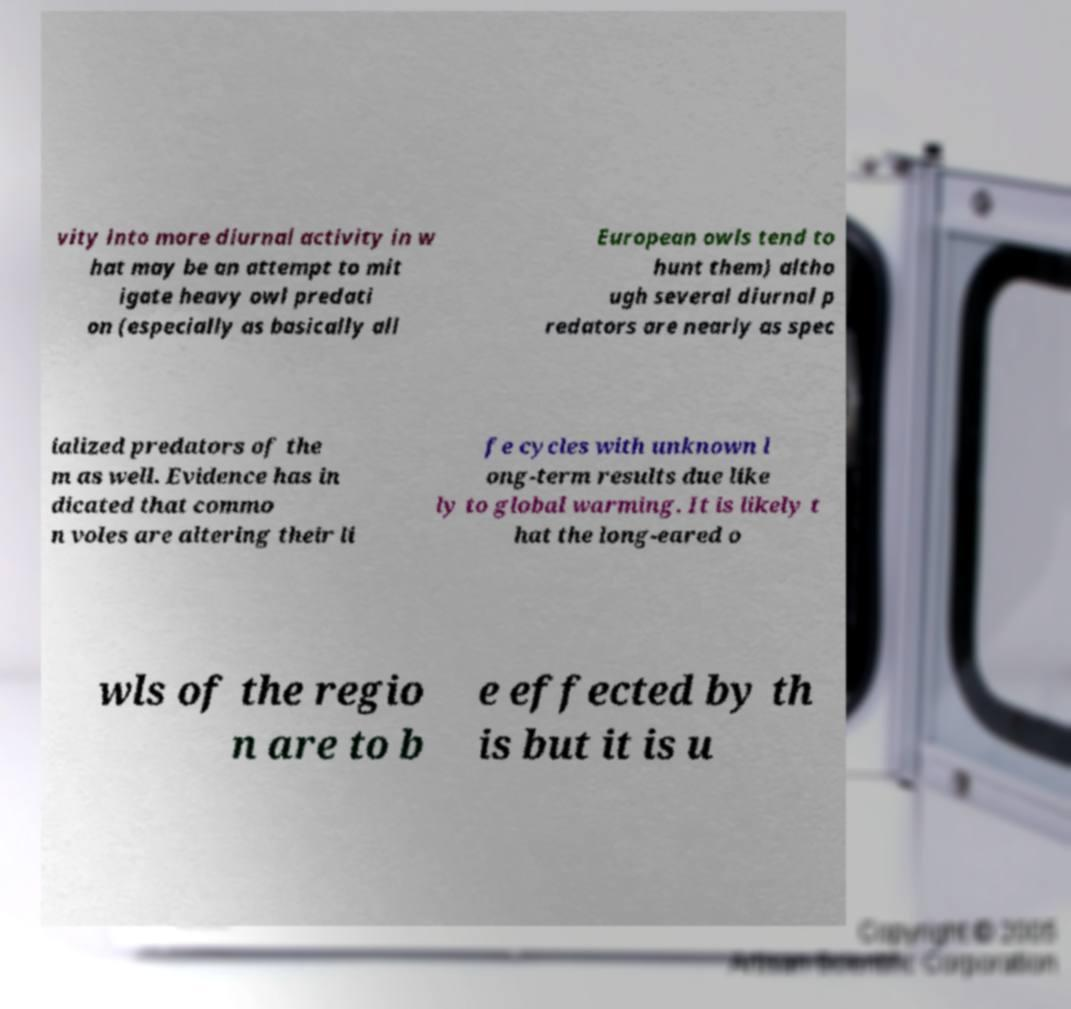Could you assist in decoding the text presented in this image and type it out clearly? vity into more diurnal activity in w hat may be an attempt to mit igate heavy owl predati on (especially as basically all European owls tend to hunt them) altho ugh several diurnal p redators are nearly as spec ialized predators of the m as well. Evidence has in dicated that commo n voles are altering their li fe cycles with unknown l ong-term results due like ly to global warming. It is likely t hat the long-eared o wls of the regio n are to b e effected by th is but it is u 